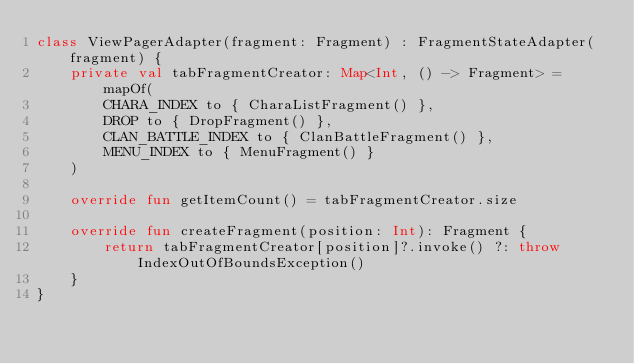Convert code to text. <code><loc_0><loc_0><loc_500><loc_500><_Kotlin_>class ViewPagerAdapter(fragment: Fragment) : FragmentStateAdapter(fragment) {
    private val tabFragmentCreator: Map<Int, () -> Fragment> = mapOf(
        CHARA_INDEX to { CharaListFragment() },
        DROP to { DropFragment() },
        CLAN_BATTLE_INDEX to { ClanBattleFragment() },
        MENU_INDEX to { MenuFragment() }
    )

    override fun getItemCount() = tabFragmentCreator.size

    override fun createFragment(position: Int): Fragment {
        return tabFragmentCreator[position]?.invoke() ?: throw IndexOutOfBoundsException()
    }
}</code> 